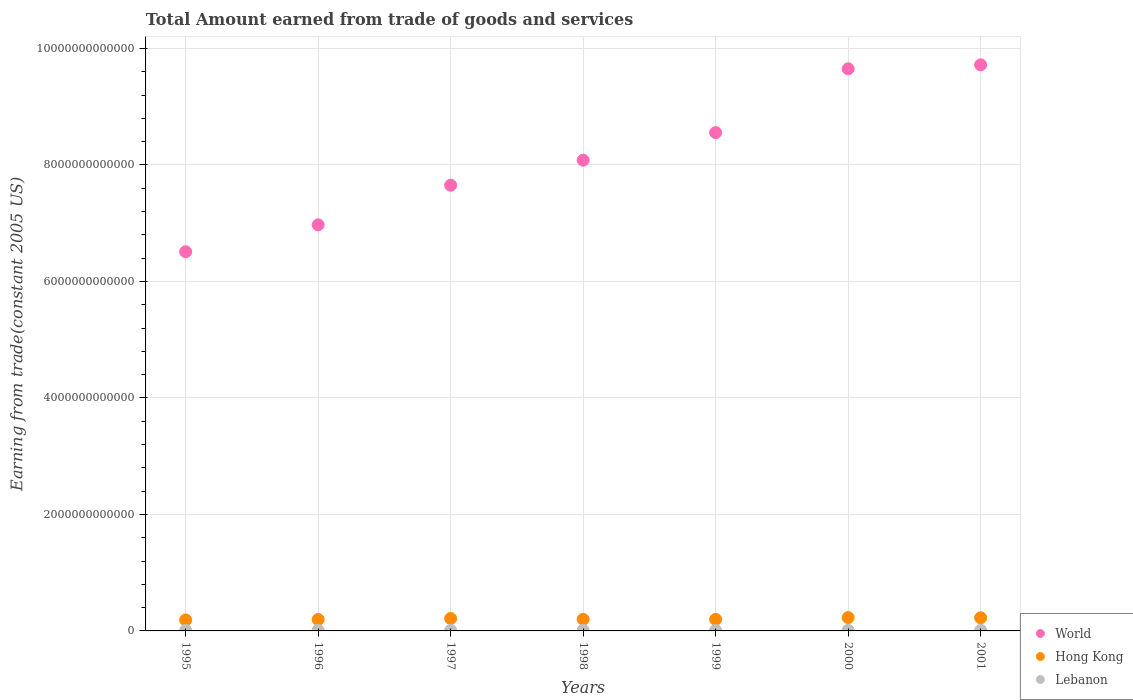Is the number of dotlines equal to the number of legend labels?
Make the answer very short. Yes. What is the total amount earned by trading goods and services in World in 2000?
Provide a succinct answer. 9.65e+12. Across all years, what is the maximum total amount earned by trading goods and services in World?
Your response must be concise. 9.72e+12. Across all years, what is the minimum total amount earned by trading goods and services in Hong Kong?
Make the answer very short. 1.88e+11. In which year was the total amount earned by trading goods and services in Lebanon minimum?
Give a very brief answer. 2000. What is the total total amount earned by trading goods and services in World in the graph?
Provide a short and direct response. 5.71e+13. What is the difference between the total amount earned by trading goods and services in Hong Kong in 1996 and that in 1998?
Offer a terse response. -3.31e+09. What is the difference between the total amount earned by trading goods and services in Lebanon in 1997 and the total amount earned by trading goods and services in Hong Kong in 1996?
Your response must be concise. -1.86e+11. What is the average total amount earned by trading goods and services in Hong Kong per year?
Make the answer very short. 2.07e+11. In the year 1997, what is the difference between the total amount earned by trading goods and services in World and total amount earned by trading goods and services in Lebanon?
Provide a short and direct response. 7.64e+12. What is the ratio of the total amount earned by trading goods and services in World in 1998 to that in 1999?
Keep it short and to the point. 0.94. Is the difference between the total amount earned by trading goods and services in World in 1996 and 2000 greater than the difference between the total amount earned by trading goods and services in Lebanon in 1996 and 2000?
Your answer should be compact. No. What is the difference between the highest and the second highest total amount earned by trading goods and services in Lebanon?
Provide a succinct answer. 4.24e+08. What is the difference between the highest and the lowest total amount earned by trading goods and services in Hong Kong?
Give a very brief answer. 4.17e+1. Is the total amount earned by trading goods and services in Lebanon strictly less than the total amount earned by trading goods and services in World over the years?
Provide a succinct answer. Yes. How many years are there in the graph?
Your answer should be very brief. 7. What is the difference between two consecutive major ticks on the Y-axis?
Provide a short and direct response. 2.00e+12. Are the values on the major ticks of Y-axis written in scientific E-notation?
Offer a terse response. No. How many legend labels are there?
Make the answer very short. 3. How are the legend labels stacked?
Your response must be concise. Vertical. What is the title of the graph?
Your answer should be very brief. Total Amount earned from trade of goods and services. Does "Caribbean small states" appear as one of the legend labels in the graph?
Provide a short and direct response. No. What is the label or title of the Y-axis?
Keep it short and to the point. Earning from trade(constant 2005 US). What is the Earning from trade(constant 2005 US) of World in 1995?
Provide a short and direct response. 6.51e+12. What is the Earning from trade(constant 2005 US) in Hong Kong in 1995?
Ensure brevity in your answer.  1.88e+11. What is the Earning from trade(constant 2005 US) in Lebanon in 1995?
Your response must be concise. 1.04e+1. What is the Earning from trade(constant 2005 US) in World in 1996?
Your answer should be very brief. 6.97e+12. What is the Earning from trade(constant 2005 US) of Hong Kong in 1996?
Keep it short and to the point. 1.96e+11. What is the Earning from trade(constant 2005 US) in Lebanon in 1996?
Keep it short and to the point. 1.07e+1. What is the Earning from trade(constant 2005 US) of World in 1997?
Provide a succinct answer. 7.65e+12. What is the Earning from trade(constant 2005 US) in Hong Kong in 1997?
Keep it short and to the point. 2.13e+11. What is the Earning from trade(constant 2005 US) of Lebanon in 1997?
Offer a very short reply. 1.02e+1. What is the Earning from trade(constant 2005 US) in World in 1998?
Your answer should be compact. 8.08e+12. What is the Earning from trade(constant 2005 US) of Hong Kong in 1998?
Your answer should be compact. 1.99e+11. What is the Earning from trade(constant 2005 US) of Lebanon in 1998?
Provide a short and direct response. 1.04e+1. What is the Earning from trade(constant 2005 US) in World in 1999?
Provide a short and direct response. 8.55e+12. What is the Earning from trade(constant 2005 US) in Hong Kong in 1999?
Offer a very short reply. 1.97e+11. What is the Earning from trade(constant 2005 US) of Lebanon in 1999?
Your response must be concise. 9.71e+09. What is the Earning from trade(constant 2005 US) in World in 2000?
Offer a very short reply. 9.65e+12. What is the Earning from trade(constant 2005 US) of Hong Kong in 2000?
Your answer should be compact. 2.30e+11. What is the Earning from trade(constant 2005 US) in Lebanon in 2000?
Make the answer very short. 9.20e+09. What is the Earning from trade(constant 2005 US) of World in 2001?
Offer a terse response. 9.72e+12. What is the Earning from trade(constant 2005 US) of Hong Kong in 2001?
Offer a very short reply. 2.26e+11. What is the Earning from trade(constant 2005 US) of Lebanon in 2001?
Keep it short and to the point. 1.11e+1. Across all years, what is the maximum Earning from trade(constant 2005 US) in World?
Provide a succinct answer. 9.72e+12. Across all years, what is the maximum Earning from trade(constant 2005 US) of Hong Kong?
Keep it short and to the point. 2.30e+11. Across all years, what is the maximum Earning from trade(constant 2005 US) in Lebanon?
Offer a terse response. 1.11e+1. Across all years, what is the minimum Earning from trade(constant 2005 US) in World?
Give a very brief answer. 6.51e+12. Across all years, what is the minimum Earning from trade(constant 2005 US) of Hong Kong?
Provide a short and direct response. 1.88e+11. Across all years, what is the minimum Earning from trade(constant 2005 US) in Lebanon?
Provide a short and direct response. 9.20e+09. What is the total Earning from trade(constant 2005 US) in World in the graph?
Keep it short and to the point. 5.71e+13. What is the total Earning from trade(constant 2005 US) in Hong Kong in the graph?
Your answer should be very brief. 1.45e+12. What is the total Earning from trade(constant 2005 US) of Lebanon in the graph?
Provide a succinct answer. 7.17e+1. What is the difference between the Earning from trade(constant 2005 US) of World in 1995 and that in 1996?
Offer a very short reply. -4.62e+11. What is the difference between the Earning from trade(constant 2005 US) of Hong Kong in 1995 and that in 1996?
Offer a very short reply. -8.17e+09. What is the difference between the Earning from trade(constant 2005 US) in Lebanon in 1995 and that in 1996?
Give a very brief answer. -3.06e+08. What is the difference between the Earning from trade(constant 2005 US) in World in 1995 and that in 1997?
Offer a very short reply. -1.14e+12. What is the difference between the Earning from trade(constant 2005 US) of Hong Kong in 1995 and that in 1997?
Give a very brief answer. -2.56e+1. What is the difference between the Earning from trade(constant 2005 US) in Lebanon in 1995 and that in 1997?
Give a very brief answer. 1.89e+08. What is the difference between the Earning from trade(constant 2005 US) in World in 1995 and that in 1998?
Keep it short and to the point. -1.57e+12. What is the difference between the Earning from trade(constant 2005 US) in Hong Kong in 1995 and that in 1998?
Your answer should be very brief. -1.15e+1. What is the difference between the Earning from trade(constant 2005 US) in Lebanon in 1995 and that in 1998?
Keep it short and to the point. 5.66e+07. What is the difference between the Earning from trade(constant 2005 US) of World in 1995 and that in 1999?
Make the answer very short. -2.05e+12. What is the difference between the Earning from trade(constant 2005 US) in Hong Kong in 1995 and that in 1999?
Make the answer very short. -9.61e+09. What is the difference between the Earning from trade(constant 2005 US) in Lebanon in 1995 and that in 1999?
Offer a very short reply. 6.98e+08. What is the difference between the Earning from trade(constant 2005 US) in World in 1995 and that in 2000?
Ensure brevity in your answer.  -3.14e+12. What is the difference between the Earning from trade(constant 2005 US) of Hong Kong in 1995 and that in 2000?
Your response must be concise. -4.17e+1. What is the difference between the Earning from trade(constant 2005 US) of Lebanon in 1995 and that in 2000?
Keep it short and to the point. 1.20e+09. What is the difference between the Earning from trade(constant 2005 US) of World in 1995 and that in 2001?
Keep it short and to the point. -3.21e+12. What is the difference between the Earning from trade(constant 2005 US) of Hong Kong in 1995 and that in 2001?
Provide a succinct answer. -3.81e+1. What is the difference between the Earning from trade(constant 2005 US) in Lebanon in 1995 and that in 2001?
Your response must be concise. -7.30e+08. What is the difference between the Earning from trade(constant 2005 US) in World in 1996 and that in 1997?
Give a very brief answer. -6.80e+11. What is the difference between the Earning from trade(constant 2005 US) in Hong Kong in 1996 and that in 1997?
Provide a short and direct response. -1.74e+1. What is the difference between the Earning from trade(constant 2005 US) in Lebanon in 1996 and that in 1997?
Give a very brief answer. 4.95e+08. What is the difference between the Earning from trade(constant 2005 US) of World in 1996 and that in 1998?
Your answer should be very brief. -1.11e+12. What is the difference between the Earning from trade(constant 2005 US) of Hong Kong in 1996 and that in 1998?
Offer a terse response. -3.31e+09. What is the difference between the Earning from trade(constant 2005 US) of Lebanon in 1996 and that in 1998?
Offer a terse response. 3.63e+08. What is the difference between the Earning from trade(constant 2005 US) in World in 1996 and that in 1999?
Provide a short and direct response. -1.58e+12. What is the difference between the Earning from trade(constant 2005 US) in Hong Kong in 1996 and that in 1999?
Your answer should be very brief. -1.44e+09. What is the difference between the Earning from trade(constant 2005 US) in Lebanon in 1996 and that in 1999?
Provide a succinct answer. 1.00e+09. What is the difference between the Earning from trade(constant 2005 US) of World in 1996 and that in 2000?
Give a very brief answer. -2.68e+12. What is the difference between the Earning from trade(constant 2005 US) in Hong Kong in 1996 and that in 2000?
Your answer should be compact. -3.35e+1. What is the difference between the Earning from trade(constant 2005 US) in Lebanon in 1996 and that in 2000?
Keep it short and to the point. 1.51e+09. What is the difference between the Earning from trade(constant 2005 US) of World in 1996 and that in 2001?
Ensure brevity in your answer.  -2.75e+12. What is the difference between the Earning from trade(constant 2005 US) in Hong Kong in 1996 and that in 2001?
Your answer should be very brief. -2.99e+1. What is the difference between the Earning from trade(constant 2005 US) of Lebanon in 1996 and that in 2001?
Provide a short and direct response. -4.24e+08. What is the difference between the Earning from trade(constant 2005 US) in World in 1997 and that in 1998?
Your answer should be compact. -4.30e+11. What is the difference between the Earning from trade(constant 2005 US) of Hong Kong in 1997 and that in 1998?
Provide a succinct answer. 1.41e+1. What is the difference between the Earning from trade(constant 2005 US) of Lebanon in 1997 and that in 1998?
Your answer should be very brief. -1.33e+08. What is the difference between the Earning from trade(constant 2005 US) in World in 1997 and that in 1999?
Your answer should be very brief. -9.03e+11. What is the difference between the Earning from trade(constant 2005 US) in Hong Kong in 1997 and that in 1999?
Give a very brief answer. 1.60e+1. What is the difference between the Earning from trade(constant 2005 US) in Lebanon in 1997 and that in 1999?
Your answer should be very brief. 5.09e+08. What is the difference between the Earning from trade(constant 2005 US) of World in 1997 and that in 2000?
Offer a very short reply. -2.00e+12. What is the difference between the Earning from trade(constant 2005 US) in Hong Kong in 1997 and that in 2000?
Provide a short and direct response. -1.61e+1. What is the difference between the Earning from trade(constant 2005 US) in Lebanon in 1997 and that in 2000?
Your response must be concise. 1.01e+09. What is the difference between the Earning from trade(constant 2005 US) in World in 1997 and that in 2001?
Your answer should be very brief. -2.07e+12. What is the difference between the Earning from trade(constant 2005 US) of Hong Kong in 1997 and that in 2001?
Provide a short and direct response. -1.25e+1. What is the difference between the Earning from trade(constant 2005 US) in Lebanon in 1997 and that in 2001?
Offer a very short reply. -9.19e+08. What is the difference between the Earning from trade(constant 2005 US) in World in 1998 and that in 1999?
Provide a short and direct response. -4.73e+11. What is the difference between the Earning from trade(constant 2005 US) of Hong Kong in 1998 and that in 1999?
Keep it short and to the point. 1.87e+09. What is the difference between the Earning from trade(constant 2005 US) of Lebanon in 1998 and that in 1999?
Your response must be concise. 6.42e+08. What is the difference between the Earning from trade(constant 2005 US) of World in 1998 and that in 2000?
Your answer should be compact. -1.57e+12. What is the difference between the Earning from trade(constant 2005 US) in Hong Kong in 1998 and that in 2000?
Your response must be concise. -3.02e+1. What is the difference between the Earning from trade(constant 2005 US) of Lebanon in 1998 and that in 2000?
Provide a short and direct response. 1.15e+09. What is the difference between the Earning from trade(constant 2005 US) of World in 1998 and that in 2001?
Provide a short and direct response. -1.64e+12. What is the difference between the Earning from trade(constant 2005 US) in Hong Kong in 1998 and that in 2001?
Provide a short and direct response. -2.66e+1. What is the difference between the Earning from trade(constant 2005 US) in Lebanon in 1998 and that in 2001?
Offer a terse response. -7.86e+08. What is the difference between the Earning from trade(constant 2005 US) of World in 1999 and that in 2000?
Your answer should be compact. -1.10e+12. What is the difference between the Earning from trade(constant 2005 US) of Hong Kong in 1999 and that in 2000?
Provide a succinct answer. -3.21e+1. What is the difference between the Earning from trade(constant 2005 US) of Lebanon in 1999 and that in 2000?
Your response must be concise. 5.05e+08. What is the difference between the Earning from trade(constant 2005 US) in World in 1999 and that in 2001?
Give a very brief answer. -1.16e+12. What is the difference between the Earning from trade(constant 2005 US) in Hong Kong in 1999 and that in 2001?
Your answer should be very brief. -2.85e+1. What is the difference between the Earning from trade(constant 2005 US) of Lebanon in 1999 and that in 2001?
Offer a very short reply. -1.43e+09. What is the difference between the Earning from trade(constant 2005 US) in World in 2000 and that in 2001?
Offer a very short reply. -6.79e+1. What is the difference between the Earning from trade(constant 2005 US) in Hong Kong in 2000 and that in 2001?
Your answer should be very brief. 3.57e+09. What is the difference between the Earning from trade(constant 2005 US) of Lebanon in 2000 and that in 2001?
Your response must be concise. -1.93e+09. What is the difference between the Earning from trade(constant 2005 US) in World in 1995 and the Earning from trade(constant 2005 US) in Hong Kong in 1996?
Your answer should be compact. 6.31e+12. What is the difference between the Earning from trade(constant 2005 US) in World in 1995 and the Earning from trade(constant 2005 US) in Lebanon in 1996?
Provide a short and direct response. 6.50e+12. What is the difference between the Earning from trade(constant 2005 US) of Hong Kong in 1995 and the Earning from trade(constant 2005 US) of Lebanon in 1996?
Ensure brevity in your answer.  1.77e+11. What is the difference between the Earning from trade(constant 2005 US) of World in 1995 and the Earning from trade(constant 2005 US) of Hong Kong in 1997?
Offer a terse response. 6.30e+12. What is the difference between the Earning from trade(constant 2005 US) in World in 1995 and the Earning from trade(constant 2005 US) in Lebanon in 1997?
Keep it short and to the point. 6.50e+12. What is the difference between the Earning from trade(constant 2005 US) of Hong Kong in 1995 and the Earning from trade(constant 2005 US) of Lebanon in 1997?
Your answer should be very brief. 1.78e+11. What is the difference between the Earning from trade(constant 2005 US) in World in 1995 and the Earning from trade(constant 2005 US) in Hong Kong in 1998?
Your response must be concise. 6.31e+12. What is the difference between the Earning from trade(constant 2005 US) of World in 1995 and the Earning from trade(constant 2005 US) of Lebanon in 1998?
Ensure brevity in your answer.  6.50e+12. What is the difference between the Earning from trade(constant 2005 US) of Hong Kong in 1995 and the Earning from trade(constant 2005 US) of Lebanon in 1998?
Provide a short and direct response. 1.78e+11. What is the difference between the Earning from trade(constant 2005 US) in World in 1995 and the Earning from trade(constant 2005 US) in Hong Kong in 1999?
Make the answer very short. 6.31e+12. What is the difference between the Earning from trade(constant 2005 US) in World in 1995 and the Earning from trade(constant 2005 US) in Lebanon in 1999?
Provide a short and direct response. 6.50e+12. What is the difference between the Earning from trade(constant 2005 US) of Hong Kong in 1995 and the Earning from trade(constant 2005 US) of Lebanon in 1999?
Your answer should be very brief. 1.78e+11. What is the difference between the Earning from trade(constant 2005 US) of World in 1995 and the Earning from trade(constant 2005 US) of Hong Kong in 2000?
Provide a short and direct response. 6.28e+12. What is the difference between the Earning from trade(constant 2005 US) in World in 1995 and the Earning from trade(constant 2005 US) in Lebanon in 2000?
Ensure brevity in your answer.  6.50e+12. What is the difference between the Earning from trade(constant 2005 US) in Hong Kong in 1995 and the Earning from trade(constant 2005 US) in Lebanon in 2000?
Provide a short and direct response. 1.79e+11. What is the difference between the Earning from trade(constant 2005 US) of World in 1995 and the Earning from trade(constant 2005 US) of Hong Kong in 2001?
Your response must be concise. 6.28e+12. What is the difference between the Earning from trade(constant 2005 US) of World in 1995 and the Earning from trade(constant 2005 US) of Lebanon in 2001?
Make the answer very short. 6.50e+12. What is the difference between the Earning from trade(constant 2005 US) in Hong Kong in 1995 and the Earning from trade(constant 2005 US) in Lebanon in 2001?
Ensure brevity in your answer.  1.77e+11. What is the difference between the Earning from trade(constant 2005 US) of World in 1996 and the Earning from trade(constant 2005 US) of Hong Kong in 1997?
Make the answer very short. 6.76e+12. What is the difference between the Earning from trade(constant 2005 US) in World in 1996 and the Earning from trade(constant 2005 US) in Lebanon in 1997?
Your answer should be very brief. 6.96e+12. What is the difference between the Earning from trade(constant 2005 US) of Hong Kong in 1996 and the Earning from trade(constant 2005 US) of Lebanon in 1997?
Provide a short and direct response. 1.86e+11. What is the difference between the Earning from trade(constant 2005 US) in World in 1996 and the Earning from trade(constant 2005 US) in Hong Kong in 1998?
Give a very brief answer. 6.77e+12. What is the difference between the Earning from trade(constant 2005 US) in World in 1996 and the Earning from trade(constant 2005 US) in Lebanon in 1998?
Provide a short and direct response. 6.96e+12. What is the difference between the Earning from trade(constant 2005 US) of Hong Kong in 1996 and the Earning from trade(constant 2005 US) of Lebanon in 1998?
Ensure brevity in your answer.  1.86e+11. What is the difference between the Earning from trade(constant 2005 US) of World in 1996 and the Earning from trade(constant 2005 US) of Hong Kong in 1999?
Make the answer very short. 6.77e+12. What is the difference between the Earning from trade(constant 2005 US) in World in 1996 and the Earning from trade(constant 2005 US) in Lebanon in 1999?
Make the answer very short. 6.96e+12. What is the difference between the Earning from trade(constant 2005 US) in Hong Kong in 1996 and the Earning from trade(constant 2005 US) in Lebanon in 1999?
Keep it short and to the point. 1.86e+11. What is the difference between the Earning from trade(constant 2005 US) of World in 1996 and the Earning from trade(constant 2005 US) of Hong Kong in 2000?
Provide a short and direct response. 6.74e+12. What is the difference between the Earning from trade(constant 2005 US) in World in 1996 and the Earning from trade(constant 2005 US) in Lebanon in 2000?
Your response must be concise. 6.96e+12. What is the difference between the Earning from trade(constant 2005 US) in Hong Kong in 1996 and the Earning from trade(constant 2005 US) in Lebanon in 2000?
Give a very brief answer. 1.87e+11. What is the difference between the Earning from trade(constant 2005 US) of World in 1996 and the Earning from trade(constant 2005 US) of Hong Kong in 2001?
Provide a short and direct response. 6.75e+12. What is the difference between the Earning from trade(constant 2005 US) of World in 1996 and the Earning from trade(constant 2005 US) of Lebanon in 2001?
Provide a short and direct response. 6.96e+12. What is the difference between the Earning from trade(constant 2005 US) in Hong Kong in 1996 and the Earning from trade(constant 2005 US) in Lebanon in 2001?
Give a very brief answer. 1.85e+11. What is the difference between the Earning from trade(constant 2005 US) in World in 1997 and the Earning from trade(constant 2005 US) in Hong Kong in 1998?
Provide a succinct answer. 7.45e+12. What is the difference between the Earning from trade(constant 2005 US) of World in 1997 and the Earning from trade(constant 2005 US) of Lebanon in 1998?
Offer a very short reply. 7.64e+12. What is the difference between the Earning from trade(constant 2005 US) of Hong Kong in 1997 and the Earning from trade(constant 2005 US) of Lebanon in 1998?
Give a very brief answer. 2.03e+11. What is the difference between the Earning from trade(constant 2005 US) in World in 1997 and the Earning from trade(constant 2005 US) in Hong Kong in 1999?
Offer a very short reply. 7.45e+12. What is the difference between the Earning from trade(constant 2005 US) in World in 1997 and the Earning from trade(constant 2005 US) in Lebanon in 1999?
Provide a succinct answer. 7.64e+12. What is the difference between the Earning from trade(constant 2005 US) of Hong Kong in 1997 and the Earning from trade(constant 2005 US) of Lebanon in 1999?
Your answer should be very brief. 2.04e+11. What is the difference between the Earning from trade(constant 2005 US) of World in 1997 and the Earning from trade(constant 2005 US) of Hong Kong in 2000?
Your response must be concise. 7.42e+12. What is the difference between the Earning from trade(constant 2005 US) of World in 1997 and the Earning from trade(constant 2005 US) of Lebanon in 2000?
Give a very brief answer. 7.64e+12. What is the difference between the Earning from trade(constant 2005 US) of Hong Kong in 1997 and the Earning from trade(constant 2005 US) of Lebanon in 2000?
Keep it short and to the point. 2.04e+11. What is the difference between the Earning from trade(constant 2005 US) in World in 1997 and the Earning from trade(constant 2005 US) in Hong Kong in 2001?
Offer a very short reply. 7.43e+12. What is the difference between the Earning from trade(constant 2005 US) of World in 1997 and the Earning from trade(constant 2005 US) of Lebanon in 2001?
Offer a very short reply. 7.64e+12. What is the difference between the Earning from trade(constant 2005 US) in Hong Kong in 1997 and the Earning from trade(constant 2005 US) in Lebanon in 2001?
Give a very brief answer. 2.02e+11. What is the difference between the Earning from trade(constant 2005 US) in World in 1998 and the Earning from trade(constant 2005 US) in Hong Kong in 1999?
Keep it short and to the point. 7.88e+12. What is the difference between the Earning from trade(constant 2005 US) in World in 1998 and the Earning from trade(constant 2005 US) in Lebanon in 1999?
Give a very brief answer. 8.07e+12. What is the difference between the Earning from trade(constant 2005 US) in Hong Kong in 1998 and the Earning from trade(constant 2005 US) in Lebanon in 1999?
Give a very brief answer. 1.90e+11. What is the difference between the Earning from trade(constant 2005 US) of World in 1998 and the Earning from trade(constant 2005 US) of Hong Kong in 2000?
Your answer should be compact. 7.85e+12. What is the difference between the Earning from trade(constant 2005 US) of World in 1998 and the Earning from trade(constant 2005 US) of Lebanon in 2000?
Your answer should be very brief. 8.07e+12. What is the difference between the Earning from trade(constant 2005 US) of Hong Kong in 1998 and the Earning from trade(constant 2005 US) of Lebanon in 2000?
Ensure brevity in your answer.  1.90e+11. What is the difference between the Earning from trade(constant 2005 US) in World in 1998 and the Earning from trade(constant 2005 US) in Hong Kong in 2001?
Keep it short and to the point. 7.86e+12. What is the difference between the Earning from trade(constant 2005 US) in World in 1998 and the Earning from trade(constant 2005 US) in Lebanon in 2001?
Ensure brevity in your answer.  8.07e+12. What is the difference between the Earning from trade(constant 2005 US) in Hong Kong in 1998 and the Earning from trade(constant 2005 US) in Lebanon in 2001?
Make the answer very short. 1.88e+11. What is the difference between the Earning from trade(constant 2005 US) of World in 1999 and the Earning from trade(constant 2005 US) of Hong Kong in 2000?
Offer a terse response. 8.33e+12. What is the difference between the Earning from trade(constant 2005 US) of World in 1999 and the Earning from trade(constant 2005 US) of Lebanon in 2000?
Ensure brevity in your answer.  8.55e+12. What is the difference between the Earning from trade(constant 2005 US) of Hong Kong in 1999 and the Earning from trade(constant 2005 US) of Lebanon in 2000?
Your answer should be very brief. 1.88e+11. What is the difference between the Earning from trade(constant 2005 US) in World in 1999 and the Earning from trade(constant 2005 US) in Hong Kong in 2001?
Ensure brevity in your answer.  8.33e+12. What is the difference between the Earning from trade(constant 2005 US) in World in 1999 and the Earning from trade(constant 2005 US) in Lebanon in 2001?
Keep it short and to the point. 8.54e+12. What is the difference between the Earning from trade(constant 2005 US) of Hong Kong in 1999 and the Earning from trade(constant 2005 US) of Lebanon in 2001?
Keep it short and to the point. 1.86e+11. What is the difference between the Earning from trade(constant 2005 US) in World in 2000 and the Earning from trade(constant 2005 US) in Hong Kong in 2001?
Make the answer very short. 9.42e+12. What is the difference between the Earning from trade(constant 2005 US) of World in 2000 and the Earning from trade(constant 2005 US) of Lebanon in 2001?
Offer a terse response. 9.64e+12. What is the difference between the Earning from trade(constant 2005 US) in Hong Kong in 2000 and the Earning from trade(constant 2005 US) in Lebanon in 2001?
Provide a short and direct response. 2.18e+11. What is the average Earning from trade(constant 2005 US) in World per year?
Provide a short and direct response. 8.16e+12. What is the average Earning from trade(constant 2005 US) of Hong Kong per year?
Provide a succinct answer. 2.07e+11. What is the average Earning from trade(constant 2005 US) of Lebanon per year?
Ensure brevity in your answer.  1.02e+1. In the year 1995, what is the difference between the Earning from trade(constant 2005 US) of World and Earning from trade(constant 2005 US) of Hong Kong?
Make the answer very short. 6.32e+12. In the year 1995, what is the difference between the Earning from trade(constant 2005 US) of World and Earning from trade(constant 2005 US) of Lebanon?
Make the answer very short. 6.50e+12. In the year 1995, what is the difference between the Earning from trade(constant 2005 US) of Hong Kong and Earning from trade(constant 2005 US) of Lebanon?
Keep it short and to the point. 1.77e+11. In the year 1996, what is the difference between the Earning from trade(constant 2005 US) in World and Earning from trade(constant 2005 US) in Hong Kong?
Offer a very short reply. 6.78e+12. In the year 1996, what is the difference between the Earning from trade(constant 2005 US) in World and Earning from trade(constant 2005 US) in Lebanon?
Provide a succinct answer. 6.96e+12. In the year 1996, what is the difference between the Earning from trade(constant 2005 US) in Hong Kong and Earning from trade(constant 2005 US) in Lebanon?
Your answer should be very brief. 1.85e+11. In the year 1997, what is the difference between the Earning from trade(constant 2005 US) in World and Earning from trade(constant 2005 US) in Hong Kong?
Your response must be concise. 7.44e+12. In the year 1997, what is the difference between the Earning from trade(constant 2005 US) of World and Earning from trade(constant 2005 US) of Lebanon?
Ensure brevity in your answer.  7.64e+12. In the year 1997, what is the difference between the Earning from trade(constant 2005 US) in Hong Kong and Earning from trade(constant 2005 US) in Lebanon?
Provide a succinct answer. 2.03e+11. In the year 1998, what is the difference between the Earning from trade(constant 2005 US) in World and Earning from trade(constant 2005 US) in Hong Kong?
Offer a terse response. 7.88e+12. In the year 1998, what is the difference between the Earning from trade(constant 2005 US) of World and Earning from trade(constant 2005 US) of Lebanon?
Your answer should be compact. 8.07e+12. In the year 1998, what is the difference between the Earning from trade(constant 2005 US) of Hong Kong and Earning from trade(constant 2005 US) of Lebanon?
Offer a very short reply. 1.89e+11. In the year 1999, what is the difference between the Earning from trade(constant 2005 US) in World and Earning from trade(constant 2005 US) in Hong Kong?
Your answer should be very brief. 8.36e+12. In the year 1999, what is the difference between the Earning from trade(constant 2005 US) of World and Earning from trade(constant 2005 US) of Lebanon?
Offer a terse response. 8.55e+12. In the year 1999, what is the difference between the Earning from trade(constant 2005 US) of Hong Kong and Earning from trade(constant 2005 US) of Lebanon?
Ensure brevity in your answer.  1.88e+11. In the year 2000, what is the difference between the Earning from trade(constant 2005 US) of World and Earning from trade(constant 2005 US) of Hong Kong?
Offer a very short reply. 9.42e+12. In the year 2000, what is the difference between the Earning from trade(constant 2005 US) in World and Earning from trade(constant 2005 US) in Lebanon?
Provide a short and direct response. 9.64e+12. In the year 2000, what is the difference between the Earning from trade(constant 2005 US) in Hong Kong and Earning from trade(constant 2005 US) in Lebanon?
Give a very brief answer. 2.20e+11. In the year 2001, what is the difference between the Earning from trade(constant 2005 US) in World and Earning from trade(constant 2005 US) in Hong Kong?
Provide a succinct answer. 9.49e+12. In the year 2001, what is the difference between the Earning from trade(constant 2005 US) in World and Earning from trade(constant 2005 US) in Lebanon?
Give a very brief answer. 9.71e+12. In the year 2001, what is the difference between the Earning from trade(constant 2005 US) in Hong Kong and Earning from trade(constant 2005 US) in Lebanon?
Keep it short and to the point. 2.15e+11. What is the ratio of the Earning from trade(constant 2005 US) in World in 1995 to that in 1996?
Keep it short and to the point. 0.93. What is the ratio of the Earning from trade(constant 2005 US) in Lebanon in 1995 to that in 1996?
Your answer should be compact. 0.97. What is the ratio of the Earning from trade(constant 2005 US) in World in 1995 to that in 1997?
Make the answer very short. 0.85. What is the ratio of the Earning from trade(constant 2005 US) of Hong Kong in 1995 to that in 1997?
Make the answer very short. 0.88. What is the ratio of the Earning from trade(constant 2005 US) of Lebanon in 1995 to that in 1997?
Your response must be concise. 1.02. What is the ratio of the Earning from trade(constant 2005 US) of World in 1995 to that in 1998?
Your answer should be very brief. 0.81. What is the ratio of the Earning from trade(constant 2005 US) of Hong Kong in 1995 to that in 1998?
Your answer should be very brief. 0.94. What is the ratio of the Earning from trade(constant 2005 US) of World in 1995 to that in 1999?
Keep it short and to the point. 0.76. What is the ratio of the Earning from trade(constant 2005 US) of Hong Kong in 1995 to that in 1999?
Your answer should be very brief. 0.95. What is the ratio of the Earning from trade(constant 2005 US) in Lebanon in 1995 to that in 1999?
Your response must be concise. 1.07. What is the ratio of the Earning from trade(constant 2005 US) in World in 1995 to that in 2000?
Give a very brief answer. 0.67. What is the ratio of the Earning from trade(constant 2005 US) of Hong Kong in 1995 to that in 2000?
Provide a succinct answer. 0.82. What is the ratio of the Earning from trade(constant 2005 US) in Lebanon in 1995 to that in 2000?
Keep it short and to the point. 1.13. What is the ratio of the Earning from trade(constant 2005 US) in World in 1995 to that in 2001?
Ensure brevity in your answer.  0.67. What is the ratio of the Earning from trade(constant 2005 US) in Hong Kong in 1995 to that in 2001?
Your answer should be very brief. 0.83. What is the ratio of the Earning from trade(constant 2005 US) of Lebanon in 1995 to that in 2001?
Offer a very short reply. 0.93. What is the ratio of the Earning from trade(constant 2005 US) of World in 1996 to that in 1997?
Keep it short and to the point. 0.91. What is the ratio of the Earning from trade(constant 2005 US) of Hong Kong in 1996 to that in 1997?
Give a very brief answer. 0.92. What is the ratio of the Earning from trade(constant 2005 US) in Lebanon in 1996 to that in 1997?
Provide a succinct answer. 1.05. What is the ratio of the Earning from trade(constant 2005 US) of World in 1996 to that in 1998?
Your answer should be compact. 0.86. What is the ratio of the Earning from trade(constant 2005 US) of Hong Kong in 1996 to that in 1998?
Offer a terse response. 0.98. What is the ratio of the Earning from trade(constant 2005 US) in Lebanon in 1996 to that in 1998?
Provide a short and direct response. 1.03. What is the ratio of the Earning from trade(constant 2005 US) in World in 1996 to that in 1999?
Offer a very short reply. 0.81. What is the ratio of the Earning from trade(constant 2005 US) of Lebanon in 1996 to that in 1999?
Make the answer very short. 1.1. What is the ratio of the Earning from trade(constant 2005 US) in World in 1996 to that in 2000?
Provide a succinct answer. 0.72. What is the ratio of the Earning from trade(constant 2005 US) of Hong Kong in 1996 to that in 2000?
Give a very brief answer. 0.85. What is the ratio of the Earning from trade(constant 2005 US) in Lebanon in 1996 to that in 2000?
Keep it short and to the point. 1.16. What is the ratio of the Earning from trade(constant 2005 US) in World in 1996 to that in 2001?
Provide a succinct answer. 0.72. What is the ratio of the Earning from trade(constant 2005 US) in Hong Kong in 1996 to that in 2001?
Your answer should be compact. 0.87. What is the ratio of the Earning from trade(constant 2005 US) in Lebanon in 1996 to that in 2001?
Give a very brief answer. 0.96. What is the ratio of the Earning from trade(constant 2005 US) of World in 1997 to that in 1998?
Ensure brevity in your answer.  0.95. What is the ratio of the Earning from trade(constant 2005 US) in Hong Kong in 1997 to that in 1998?
Keep it short and to the point. 1.07. What is the ratio of the Earning from trade(constant 2005 US) in Lebanon in 1997 to that in 1998?
Offer a very short reply. 0.99. What is the ratio of the Earning from trade(constant 2005 US) of World in 1997 to that in 1999?
Provide a short and direct response. 0.89. What is the ratio of the Earning from trade(constant 2005 US) of Hong Kong in 1997 to that in 1999?
Give a very brief answer. 1.08. What is the ratio of the Earning from trade(constant 2005 US) of Lebanon in 1997 to that in 1999?
Keep it short and to the point. 1.05. What is the ratio of the Earning from trade(constant 2005 US) of World in 1997 to that in 2000?
Keep it short and to the point. 0.79. What is the ratio of the Earning from trade(constant 2005 US) in Hong Kong in 1997 to that in 2000?
Provide a succinct answer. 0.93. What is the ratio of the Earning from trade(constant 2005 US) in Lebanon in 1997 to that in 2000?
Your answer should be very brief. 1.11. What is the ratio of the Earning from trade(constant 2005 US) of World in 1997 to that in 2001?
Your answer should be compact. 0.79. What is the ratio of the Earning from trade(constant 2005 US) in Hong Kong in 1997 to that in 2001?
Make the answer very short. 0.94. What is the ratio of the Earning from trade(constant 2005 US) in Lebanon in 1997 to that in 2001?
Your response must be concise. 0.92. What is the ratio of the Earning from trade(constant 2005 US) of World in 1998 to that in 1999?
Offer a very short reply. 0.94. What is the ratio of the Earning from trade(constant 2005 US) in Hong Kong in 1998 to that in 1999?
Your response must be concise. 1.01. What is the ratio of the Earning from trade(constant 2005 US) in Lebanon in 1998 to that in 1999?
Your response must be concise. 1.07. What is the ratio of the Earning from trade(constant 2005 US) of World in 1998 to that in 2000?
Make the answer very short. 0.84. What is the ratio of the Earning from trade(constant 2005 US) in Hong Kong in 1998 to that in 2000?
Offer a terse response. 0.87. What is the ratio of the Earning from trade(constant 2005 US) of Lebanon in 1998 to that in 2000?
Make the answer very short. 1.12. What is the ratio of the Earning from trade(constant 2005 US) of World in 1998 to that in 2001?
Your answer should be compact. 0.83. What is the ratio of the Earning from trade(constant 2005 US) of Hong Kong in 1998 to that in 2001?
Make the answer very short. 0.88. What is the ratio of the Earning from trade(constant 2005 US) of Lebanon in 1998 to that in 2001?
Your response must be concise. 0.93. What is the ratio of the Earning from trade(constant 2005 US) of World in 1999 to that in 2000?
Your answer should be very brief. 0.89. What is the ratio of the Earning from trade(constant 2005 US) of Hong Kong in 1999 to that in 2000?
Your response must be concise. 0.86. What is the ratio of the Earning from trade(constant 2005 US) of Lebanon in 1999 to that in 2000?
Your answer should be compact. 1.05. What is the ratio of the Earning from trade(constant 2005 US) in World in 1999 to that in 2001?
Your answer should be very brief. 0.88. What is the ratio of the Earning from trade(constant 2005 US) of Hong Kong in 1999 to that in 2001?
Provide a succinct answer. 0.87. What is the ratio of the Earning from trade(constant 2005 US) of Lebanon in 1999 to that in 2001?
Keep it short and to the point. 0.87. What is the ratio of the Earning from trade(constant 2005 US) in Hong Kong in 2000 to that in 2001?
Keep it short and to the point. 1.02. What is the ratio of the Earning from trade(constant 2005 US) of Lebanon in 2000 to that in 2001?
Your answer should be very brief. 0.83. What is the difference between the highest and the second highest Earning from trade(constant 2005 US) in World?
Give a very brief answer. 6.79e+1. What is the difference between the highest and the second highest Earning from trade(constant 2005 US) in Hong Kong?
Provide a short and direct response. 3.57e+09. What is the difference between the highest and the second highest Earning from trade(constant 2005 US) of Lebanon?
Your response must be concise. 4.24e+08. What is the difference between the highest and the lowest Earning from trade(constant 2005 US) in World?
Provide a succinct answer. 3.21e+12. What is the difference between the highest and the lowest Earning from trade(constant 2005 US) in Hong Kong?
Give a very brief answer. 4.17e+1. What is the difference between the highest and the lowest Earning from trade(constant 2005 US) in Lebanon?
Offer a terse response. 1.93e+09. 